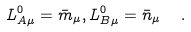<formula> <loc_0><loc_0><loc_500><loc_500>L ^ { 0 } _ { A \mu } = \bar { m } _ { \mu } , L ^ { 0 } _ { B \mu } = \bar { n } _ { \mu } \ \ .</formula> 